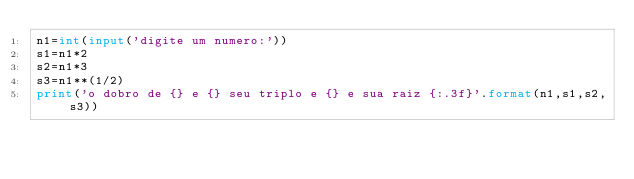<code> <loc_0><loc_0><loc_500><loc_500><_Python_>n1=int(input('digite um numero:'))
s1=n1*2
s2=n1*3
s3=n1**(1/2)
print('o dobro de {} e {} seu triplo e {} e sua raiz {:.3f}'.format(n1,s1,s2,s3))
</code> 